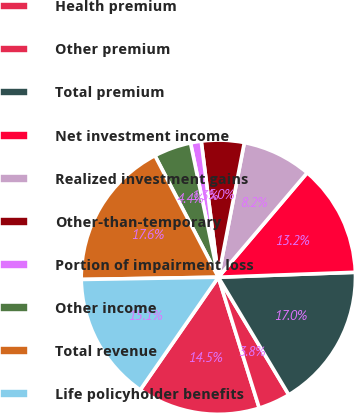Convert chart to OTSL. <chart><loc_0><loc_0><loc_500><loc_500><pie_chart><fcel>Health premium<fcel>Other premium<fcel>Total premium<fcel>Net investment income<fcel>Realized investment gains<fcel>Other-than-temporary<fcel>Portion of impairment loss<fcel>Other income<fcel>Total revenue<fcel>Life policyholder benefits<nl><fcel>14.47%<fcel>3.77%<fcel>16.98%<fcel>13.21%<fcel>8.18%<fcel>5.03%<fcel>1.26%<fcel>4.4%<fcel>17.61%<fcel>15.09%<nl></chart> 